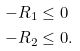<formula> <loc_0><loc_0><loc_500><loc_500>- R _ { 1 } & \leq 0 \\ - R _ { 2 } & \leq 0 .</formula> 